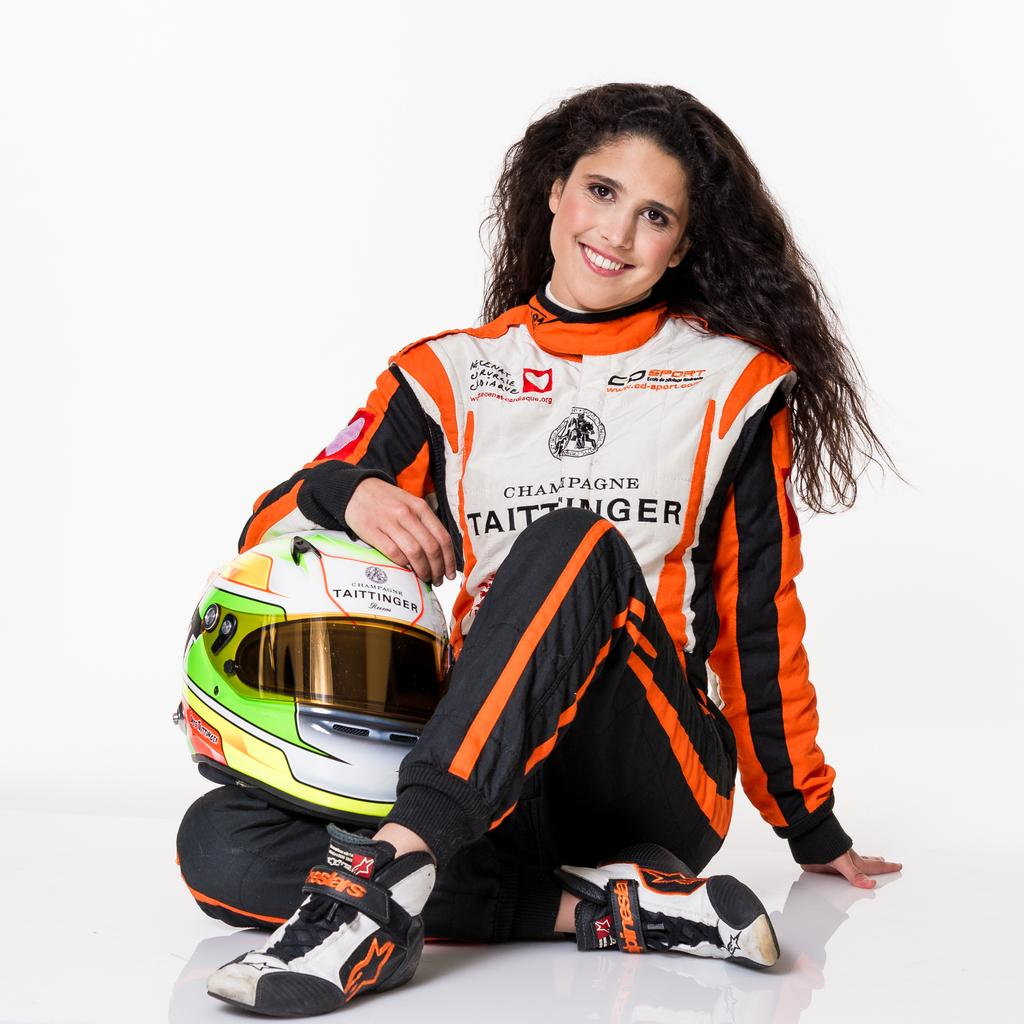Who is present in the image? There is a woman in the image. What is the woman wearing? The woman is wearing a jacket and shoes. What object is the woman holding in her hand? The woman is holding a helmet in her hand. What is the woman doing in the image? The woman is sitting and giving a pose for the picture. What is the expression on the woman's face? The woman is smiling. What is the color of the background in the image? The background of the image is white. What type of acoustics can be heard in the image? There is no sound or acoustics present in the image, as it is a still photograph. What direction is the cart facing in the image? There is no cart present in the image. 